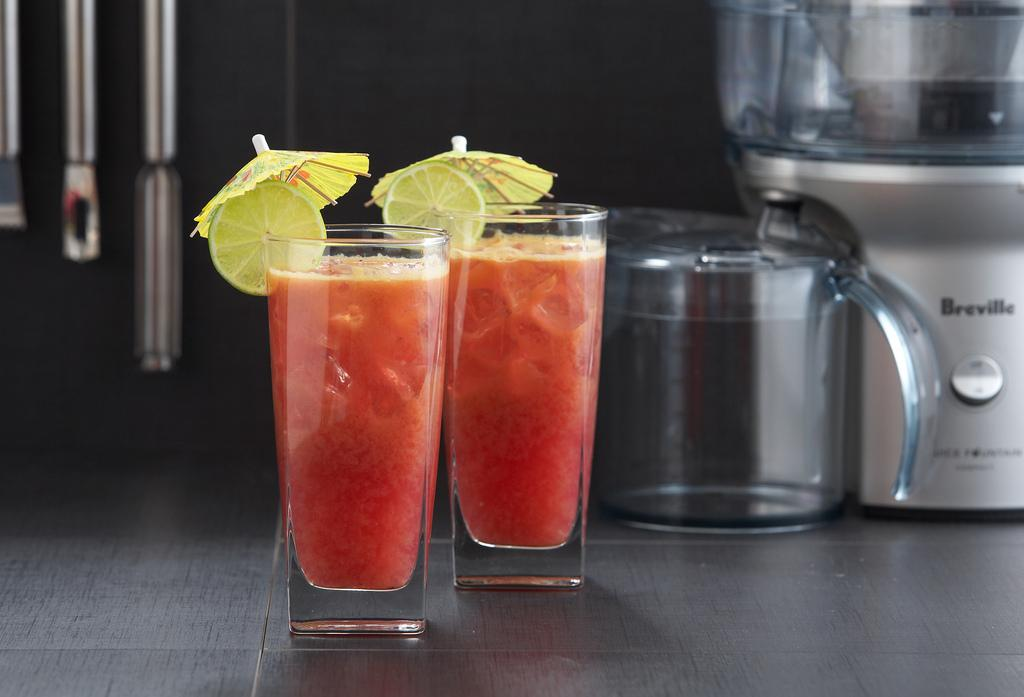<image>
Give a short and clear explanation of the subsequent image. Two drinks with umbrellas with a Breville maker behind. 